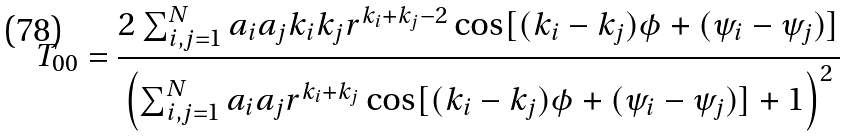<formula> <loc_0><loc_0><loc_500><loc_500>T _ { 0 0 } = \frac { 2 \sum _ { i , j = 1 } ^ { N } a _ { i } a _ { j } k _ { i } k _ { j } r ^ { k _ { i } + k _ { j } - 2 } \cos [ ( k _ { i } - k _ { j } ) \phi + ( \psi _ { i } - \psi _ { j } ) ] } { \left ( \sum _ { i , j = 1 } ^ { N } a _ { i } a _ { j } r ^ { k _ { i } + k _ { j } } \cos [ ( k _ { i } - k _ { j } ) \phi + ( \psi _ { i } - \psi _ { j } ) ] + 1 \right ) ^ { 2 } }</formula> 